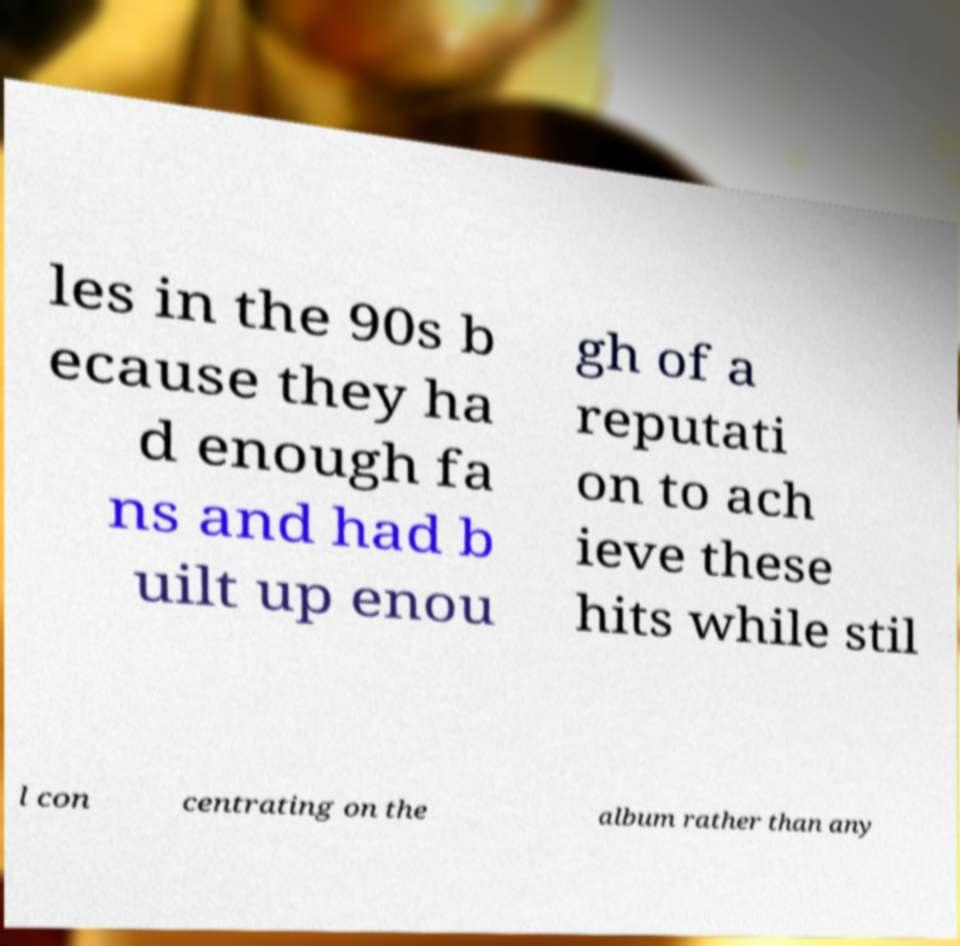Please identify and transcribe the text found in this image. les in the 90s b ecause they ha d enough fa ns and had b uilt up enou gh of a reputati on to ach ieve these hits while stil l con centrating on the album rather than any 